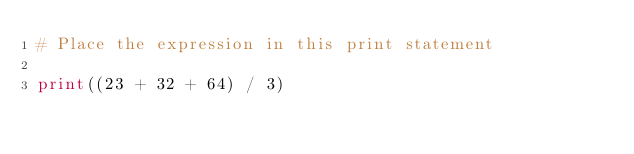Convert code to text. <code><loc_0><loc_0><loc_500><loc_500><_Python_># Place the expression in this print statement

print((23 + 32 + 64) / 3)</code> 